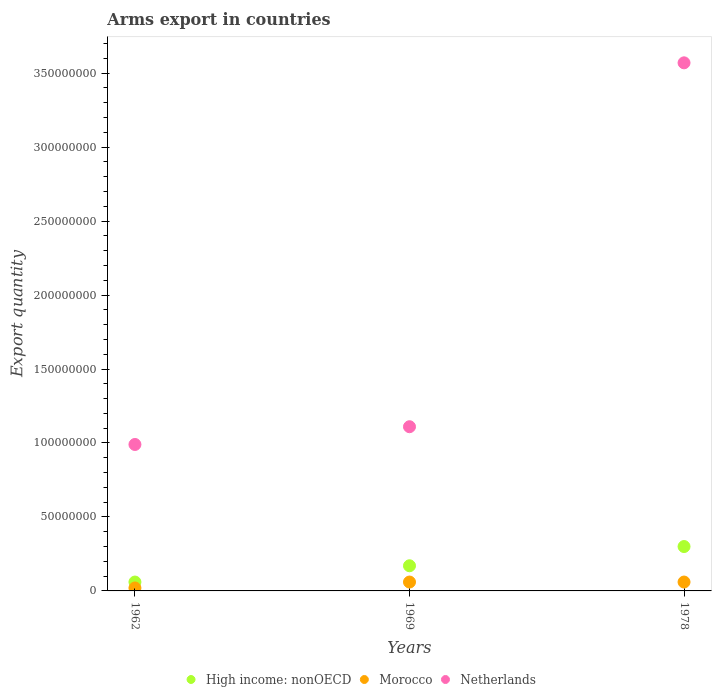How many different coloured dotlines are there?
Your response must be concise. 3. In which year was the total arms export in Morocco maximum?
Keep it short and to the point. 1969. What is the total total arms export in Netherlands in the graph?
Provide a succinct answer. 5.67e+08. What is the difference between the total arms export in Netherlands in 1962 and that in 1978?
Keep it short and to the point. -2.58e+08. What is the difference between the total arms export in High income: nonOECD in 1969 and the total arms export in Netherlands in 1962?
Give a very brief answer. -8.20e+07. What is the average total arms export in High income: nonOECD per year?
Provide a short and direct response. 1.77e+07. In the year 1969, what is the difference between the total arms export in High income: nonOECD and total arms export in Morocco?
Provide a short and direct response. 1.10e+07. What is the ratio of the total arms export in Netherlands in 1962 to that in 1969?
Provide a short and direct response. 0.89. What is the difference between the highest and the lowest total arms export in Netherlands?
Provide a succinct answer. 2.58e+08. Is the sum of the total arms export in Netherlands in 1962 and 1978 greater than the maximum total arms export in Morocco across all years?
Offer a very short reply. Yes. Does the total arms export in Morocco monotonically increase over the years?
Provide a short and direct response. No. How many years are there in the graph?
Offer a terse response. 3. Are the values on the major ticks of Y-axis written in scientific E-notation?
Provide a succinct answer. No. Does the graph contain grids?
Ensure brevity in your answer.  No. How many legend labels are there?
Your answer should be very brief. 3. What is the title of the graph?
Your response must be concise. Arms export in countries. Does "Congo (Democratic)" appear as one of the legend labels in the graph?
Offer a very short reply. No. What is the label or title of the Y-axis?
Make the answer very short. Export quantity. What is the Export quantity of Netherlands in 1962?
Offer a very short reply. 9.90e+07. What is the Export quantity of High income: nonOECD in 1969?
Provide a short and direct response. 1.70e+07. What is the Export quantity in Morocco in 1969?
Provide a short and direct response. 6.00e+06. What is the Export quantity of Netherlands in 1969?
Ensure brevity in your answer.  1.11e+08. What is the Export quantity of High income: nonOECD in 1978?
Provide a succinct answer. 3.00e+07. What is the Export quantity of Morocco in 1978?
Give a very brief answer. 6.00e+06. What is the Export quantity of Netherlands in 1978?
Ensure brevity in your answer.  3.57e+08. Across all years, what is the maximum Export quantity of High income: nonOECD?
Give a very brief answer. 3.00e+07. Across all years, what is the maximum Export quantity of Netherlands?
Your answer should be compact. 3.57e+08. Across all years, what is the minimum Export quantity in Netherlands?
Provide a succinct answer. 9.90e+07. What is the total Export quantity of High income: nonOECD in the graph?
Make the answer very short. 5.30e+07. What is the total Export quantity of Morocco in the graph?
Offer a very short reply. 1.40e+07. What is the total Export quantity in Netherlands in the graph?
Offer a very short reply. 5.67e+08. What is the difference between the Export quantity of High income: nonOECD in 1962 and that in 1969?
Your answer should be very brief. -1.10e+07. What is the difference between the Export quantity of Morocco in 1962 and that in 1969?
Provide a short and direct response. -4.00e+06. What is the difference between the Export quantity in Netherlands in 1962 and that in 1969?
Offer a terse response. -1.20e+07. What is the difference between the Export quantity in High income: nonOECD in 1962 and that in 1978?
Your response must be concise. -2.40e+07. What is the difference between the Export quantity in Morocco in 1962 and that in 1978?
Ensure brevity in your answer.  -4.00e+06. What is the difference between the Export quantity of Netherlands in 1962 and that in 1978?
Give a very brief answer. -2.58e+08. What is the difference between the Export quantity of High income: nonOECD in 1969 and that in 1978?
Ensure brevity in your answer.  -1.30e+07. What is the difference between the Export quantity in Netherlands in 1969 and that in 1978?
Provide a succinct answer. -2.46e+08. What is the difference between the Export quantity of High income: nonOECD in 1962 and the Export quantity of Morocco in 1969?
Your answer should be very brief. 0. What is the difference between the Export quantity in High income: nonOECD in 1962 and the Export quantity in Netherlands in 1969?
Your answer should be compact. -1.05e+08. What is the difference between the Export quantity of Morocco in 1962 and the Export quantity of Netherlands in 1969?
Offer a terse response. -1.09e+08. What is the difference between the Export quantity of High income: nonOECD in 1962 and the Export quantity of Netherlands in 1978?
Make the answer very short. -3.51e+08. What is the difference between the Export quantity of Morocco in 1962 and the Export quantity of Netherlands in 1978?
Your answer should be compact. -3.55e+08. What is the difference between the Export quantity in High income: nonOECD in 1969 and the Export quantity in Morocco in 1978?
Offer a terse response. 1.10e+07. What is the difference between the Export quantity of High income: nonOECD in 1969 and the Export quantity of Netherlands in 1978?
Offer a terse response. -3.40e+08. What is the difference between the Export quantity of Morocco in 1969 and the Export quantity of Netherlands in 1978?
Offer a terse response. -3.51e+08. What is the average Export quantity in High income: nonOECD per year?
Make the answer very short. 1.77e+07. What is the average Export quantity in Morocco per year?
Your answer should be compact. 4.67e+06. What is the average Export quantity of Netherlands per year?
Your answer should be compact. 1.89e+08. In the year 1962, what is the difference between the Export quantity of High income: nonOECD and Export quantity of Morocco?
Make the answer very short. 4.00e+06. In the year 1962, what is the difference between the Export quantity of High income: nonOECD and Export quantity of Netherlands?
Provide a short and direct response. -9.30e+07. In the year 1962, what is the difference between the Export quantity of Morocco and Export quantity of Netherlands?
Offer a terse response. -9.70e+07. In the year 1969, what is the difference between the Export quantity in High income: nonOECD and Export quantity in Morocco?
Make the answer very short. 1.10e+07. In the year 1969, what is the difference between the Export quantity in High income: nonOECD and Export quantity in Netherlands?
Your response must be concise. -9.40e+07. In the year 1969, what is the difference between the Export quantity of Morocco and Export quantity of Netherlands?
Your response must be concise. -1.05e+08. In the year 1978, what is the difference between the Export quantity of High income: nonOECD and Export quantity of Morocco?
Give a very brief answer. 2.40e+07. In the year 1978, what is the difference between the Export quantity of High income: nonOECD and Export quantity of Netherlands?
Your response must be concise. -3.27e+08. In the year 1978, what is the difference between the Export quantity of Morocco and Export quantity of Netherlands?
Give a very brief answer. -3.51e+08. What is the ratio of the Export quantity in High income: nonOECD in 1962 to that in 1969?
Ensure brevity in your answer.  0.35. What is the ratio of the Export quantity of Netherlands in 1962 to that in 1969?
Offer a very short reply. 0.89. What is the ratio of the Export quantity of Morocco in 1962 to that in 1978?
Your answer should be compact. 0.33. What is the ratio of the Export quantity of Netherlands in 1962 to that in 1978?
Give a very brief answer. 0.28. What is the ratio of the Export quantity of High income: nonOECD in 1969 to that in 1978?
Ensure brevity in your answer.  0.57. What is the ratio of the Export quantity of Netherlands in 1969 to that in 1978?
Provide a succinct answer. 0.31. What is the difference between the highest and the second highest Export quantity of High income: nonOECD?
Your answer should be compact. 1.30e+07. What is the difference between the highest and the second highest Export quantity in Morocco?
Your answer should be very brief. 0. What is the difference between the highest and the second highest Export quantity in Netherlands?
Ensure brevity in your answer.  2.46e+08. What is the difference between the highest and the lowest Export quantity in High income: nonOECD?
Provide a short and direct response. 2.40e+07. What is the difference between the highest and the lowest Export quantity of Morocco?
Keep it short and to the point. 4.00e+06. What is the difference between the highest and the lowest Export quantity of Netherlands?
Keep it short and to the point. 2.58e+08. 